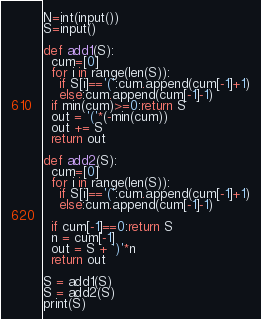Convert code to text. <code><loc_0><loc_0><loc_500><loc_500><_Python_>N=int(input())
S=input()

def add1(S):
  cum=[0]
  for i in range(len(S)):
    if S[i]=='(':cum.append(cum[-1]+1)
    else:cum.append(cum[-1]-1)
  if min(cum)>=0:return S
  out = '('*(-min(cum))
  out += S
  return out

def add2(S):
  cum=[0]
  for i in range(len(S)):
    if S[i]=='(':cum.append(cum[-1]+1)
    else:cum.append(cum[-1]-1)
      
  if cum[-1]==0:return S
  n = cum[-1]
  out = S + ')'*n
  return out

S = add1(S)
S = add2(S)
print(S)</code> 